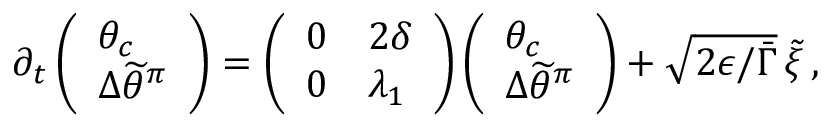Convert formula to latex. <formula><loc_0><loc_0><loc_500><loc_500>\begin{array} { r } { \partial _ { t } \left ( \begin{array} { l } { \theta _ { c } } \\ { { \Delta \widetilde { \theta } ^ { \pi } } } \end{array} \right ) = \left ( \begin{array} { l l } { 0 } & { 2 \delta } \\ { 0 } & { \lambda _ { 1 } } \end{array} \right ) \left ( \begin{array} { l } { \theta _ { c } } \\ { { \Delta \widetilde { \theta } ^ { \pi } } } \end{array} \right ) + \sqrt { 2 \epsilon / \bar { \Gamma } } \, \tilde { \xi } \, , } \end{array}</formula> 